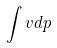<formula> <loc_0><loc_0><loc_500><loc_500>\int v d p</formula> 